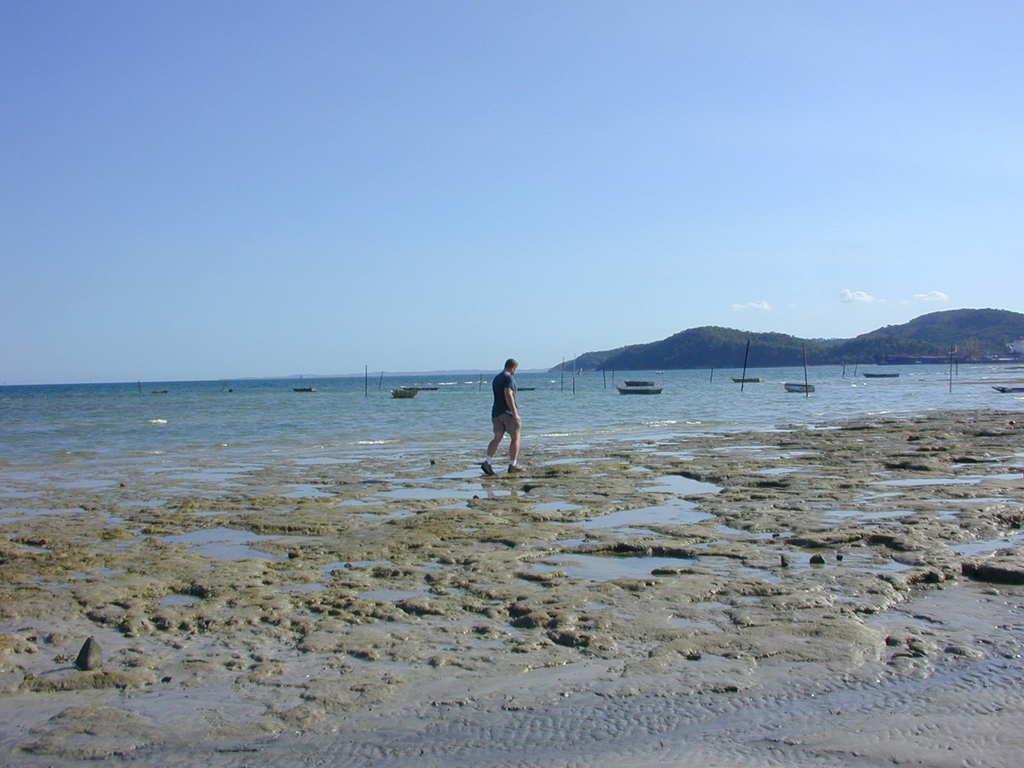Describe this image in one or two sentences. In this image there is the sky, there are mountains truncated towards the right of the image, there are poles, there is the sea, there are objects on the sea, there is a person walking, there is an object truncated towards the right of the image. 